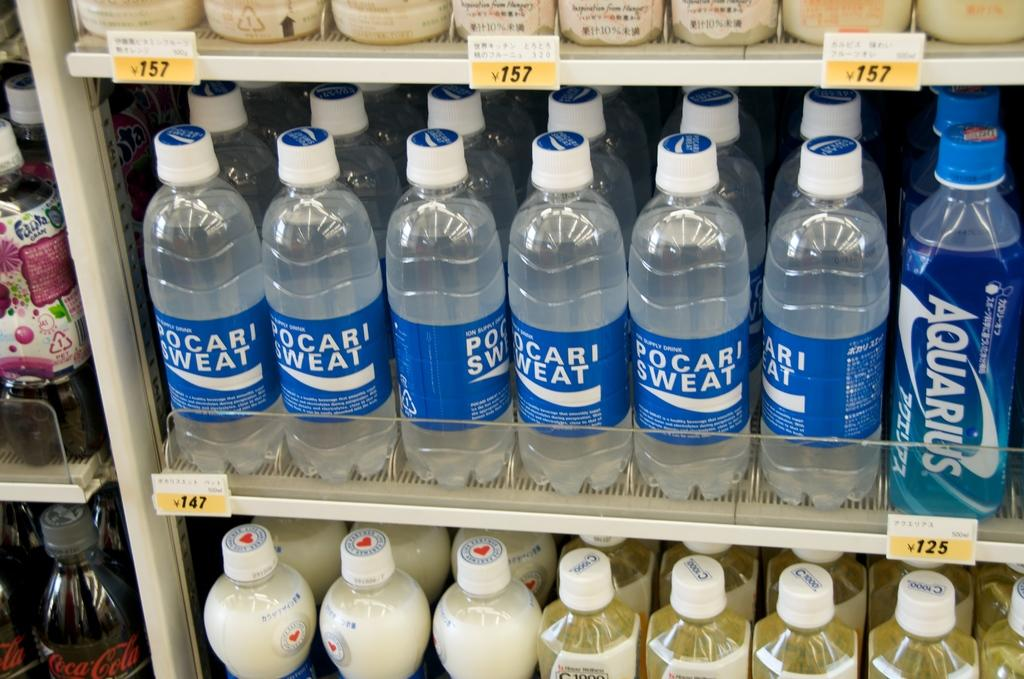What objects are visible in the image? There are water bottles in the image. How are the water bottles arranged? The water bottles are arranged in rows. Where are the water bottles located? The water bottles are in a rack. What type of spade can be seen in the image? There is no spade present in the image; it only features water bottles arranged in rows in a rack. 